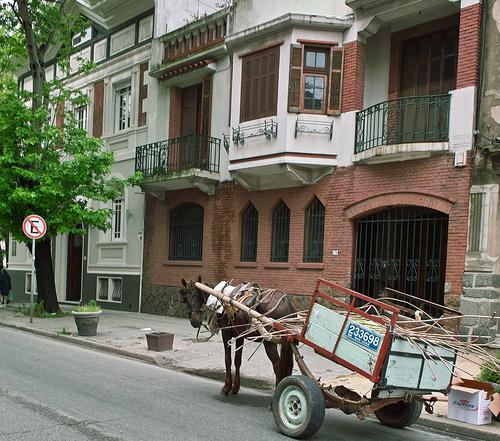What is the wooden box attached to?
Concise answer only. Horse. What color are the tree leaves?
Short answer required. Green. Is the mule sleeping?
Be succinct. No. How many balconies are there in the picture?
Be succinct. 2. 